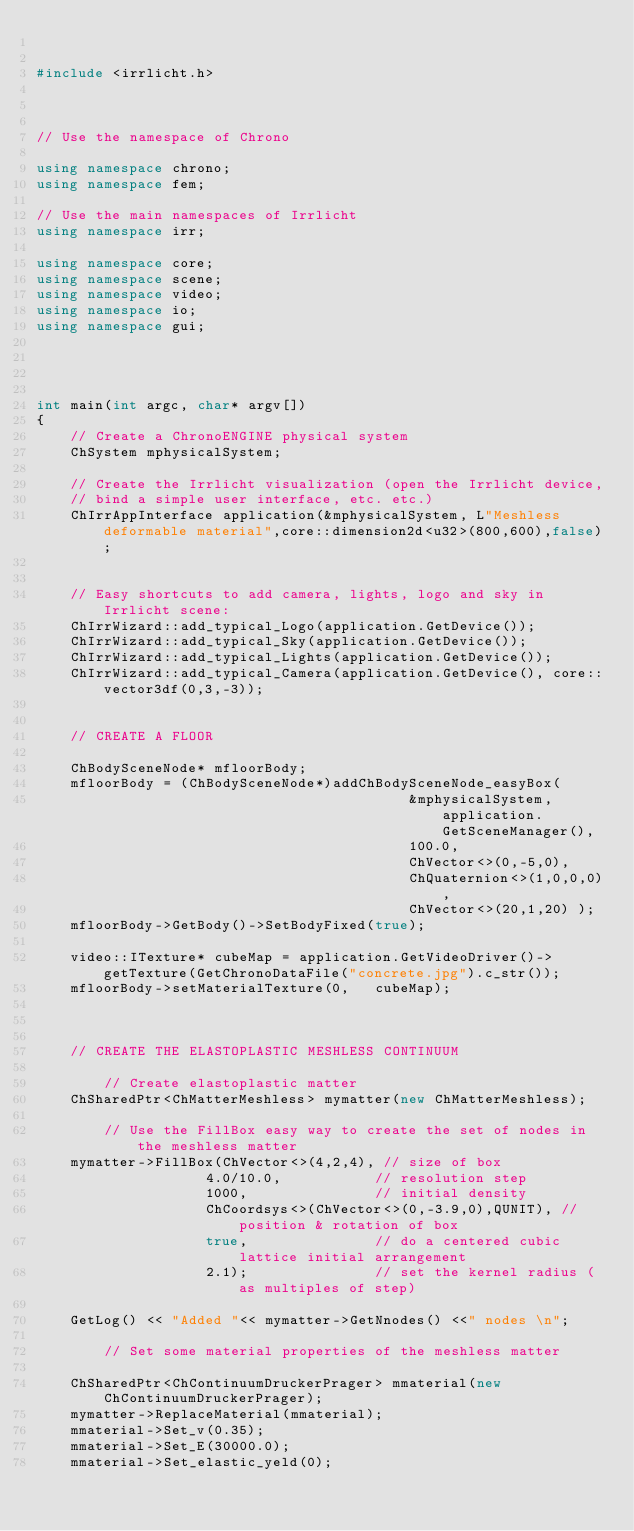<code> <loc_0><loc_0><loc_500><loc_500><_C++_>

#include <irrlicht.h>
 


// Use the namespace of Chrono

using namespace chrono;
using namespace fem;

// Use the main namespaces of Irrlicht
using namespace irr;
         
using namespace core;
using namespace scene; 
using namespace video;
using namespace io; 
using namespace gui; 


   
 
int main(int argc, char* argv[])
{
	// Create a ChronoENGINE physical system
	ChSystem mphysicalSystem;

	// Create the Irrlicht visualization (open the Irrlicht device, 
	// bind a simple user interface, etc. etc.)
	ChIrrAppInterface application(&mphysicalSystem, L"Meshless deformable material",core::dimension2d<u32>(800,600),false);


	// Easy shortcuts to add camera, lights, logo and sky in Irrlicht scene:
	ChIrrWizard::add_typical_Logo(application.GetDevice());
	ChIrrWizard::add_typical_Sky(application.GetDevice());
	ChIrrWizard::add_typical_Lights(application.GetDevice());
	ChIrrWizard::add_typical_Camera(application.GetDevice(), core::vector3df(0,3,-3));

 
	// CREATE A FLOOR

	ChBodySceneNode* mfloorBody; 
	mfloorBody = (ChBodySceneNode*)addChBodySceneNode_easyBox(
											&mphysicalSystem, application.GetSceneManager(),
											100.0,
											ChVector<>(0,-5,0),
											ChQuaternion<>(1,0,0,0), 
											ChVector<>(20,1,20) );
	mfloorBody->GetBody()->SetBodyFixed(true);

	video::ITexture* cubeMap = application.GetVideoDriver()->getTexture(GetChronoDataFile("concrete.jpg").c_str());
	mfloorBody->setMaterialTexture(0,	cubeMap);



	// CREATE THE ELASTOPLASTIC MESHLESS CONTINUUM

		// Create elastoplastic matter
	ChSharedPtr<ChMatterMeshless> mymatter(new ChMatterMeshless);

		// Use the FillBox easy way to create the set of nodes in the meshless matter
	mymatter->FillBox(ChVector<>(4,2,4), // size of box 
					4.0/10.0,			// resolution step
					1000,				// initial density
					ChCoordsys<>(ChVector<>(0,-3.9,0),QUNIT), // position & rotation of box
					true,				// do a centered cubic lattice initial arrangement 
					2.1);				// set the kernel radius (as multiples of step)

	GetLog() << "Added "<< mymatter->GetNnodes() <<" nodes \n";

		// Set some material properties of the meshless matter
	
	ChSharedPtr<ChContinuumDruckerPrager> mmaterial(new ChContinuumDruckerPrager);
	mymatter->ReplaceMaterial(mmaterial); 
	mmaterial->Set_v(0.35);
	mmaterial->Set_E(30000.0);
	mmaterial->Set_elastic_yeld(0);</code> 